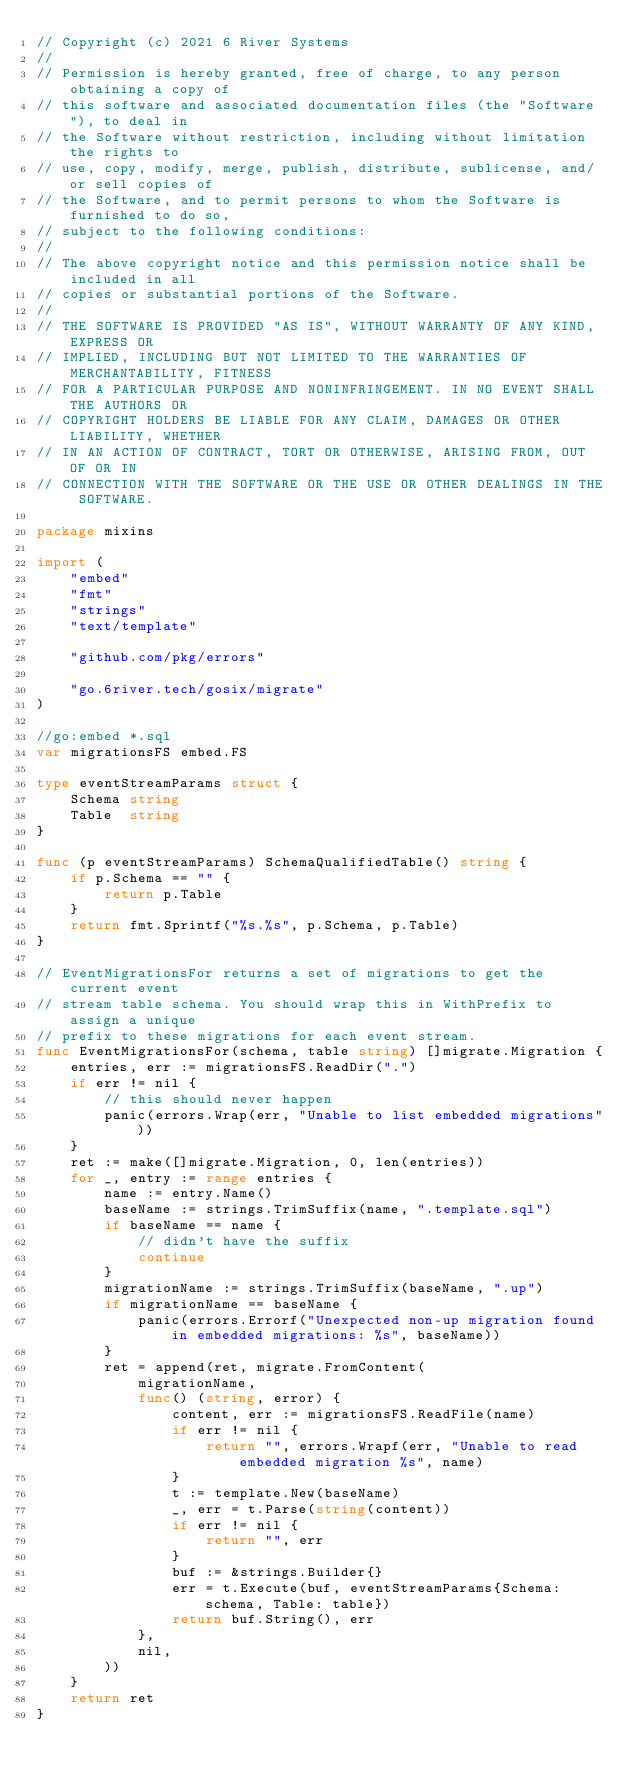<code> <loc_0><loc_0><loc_500><loc_500><_Go_>// Copyright (c) 2021 6 River Systems
//
// Permission is hereby granted, free of charge, to any person obtaining a copy of
// this software and associated documentation files (the "Software"), to deal in
// the Software without restriction, including without limitation the rights to
// use, copy, modify, merge, publish, distribute, sublicense, and/or sell copies of
// the Software, and to permit persons to whom the Software is furnished to do so,
// subject to the following conditions:
//
// The above copyright notice and this permission notice shall be included in all
// copies or substantial portions of the Software.
//
// THE SOFTWARE IS PROVIDED "AS IS", WITHOUT WARRANTY OF ANY KIND, EXPRESS OR
// IMPLIED, INCLUDING BUT NOT LIMITED TO THE WARRANTIES OF MERCHANTABILITY, FITNESS
// FOR A PARTICULAR PURPOSE AND NONINFRINGEMENT. IN NO EVENT SHALL THE AUTHORS OR
// COPYRIGHT HOLDERS BE LIABLE FOR ANY CLAIM, DAMAGES OR OTHER LIABILITY, WHETHER
// IN AN ACTION OF CONTRACT, TORT OR OTHERWISE, ARISING FROM, OUT OF OR IN
// CONNECTION WITH THE SOFTWARE OR THE USE OR OTHER DEALINGS IN THE SOFTWARE.

package mixins

import (
	"embed"
	"fmt"
	"strings"
	"text/template"

	"github.com/pkg/errors"

	"go.6river.tech/gosix/migrate"
)

//go:embed *.sql
var migrationsFS embed.FS

type eventStreamParams struct {
	Schema string
	Table  string
}

func (p eventStreamParams) SchemaQualifiedTable() string {
	if p.Schema == "" {
		return p.Table
	}
	return fmt.Sprintf("%s.%s", p.Schema, p.Table)
}

// EventMigrationsFor returns a set of migrations to get the current event
// stream table schema. You should wrap this in WithPrefix to assign a unique
// prefix to these migrations for each event stream.
func EventMigrationsFor(schema, table string) []migrate.Migration {
	entries, err := migrationsFS.ReadDir(".")
	if err != nil {
		// this should never happen
		panic(errors.Wrap(err, "Unable to list embedded migrations"))
	}
	ret := make([]migrate.Migration, 0, len(entries))
	for _, entry := range entries {
		name := entry.Name()
		baseName := strings.TrimSuffix(name, ".template.sql")
		if baseName == name {
			// didn't have the suffix
			continue
		}
		migrationName := strings.TrimSuffix(baseName, ".up")
		if migrationName == baseName {
			panic(errors.Errorf("Unexpected non-up migration found in embedded migrations: %s", baseName))
		}
		ret = append(ret, migrate.FromContent(
			migrationName,
			func() (string, error) {
				content, err := migrationsFS.ReadFile(name)
				if err != nil {
					return "", errors.Wrapf(err, "Unable to read embedded migration %s", name)
				}
				t := template.New(baseName)
				_, err = t.Parse(string(content))
				if err != nil {
					return "", err
				}
				buf := &strings.Builder{}
				err = t.Execute(buf, eventStreamParams{Schema: schema, Table: table})
				return buf.String(), err
			},
			nil,
		))
	}
	return ret
}
</code> 